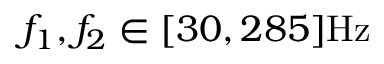Convert formula to latex. <formula><loc_0><loc_0><loc_500><loc_500>f _ { 1 } , f _ { 2 } \in [ 3 0 , 2 8 5 ] H z</formula> 